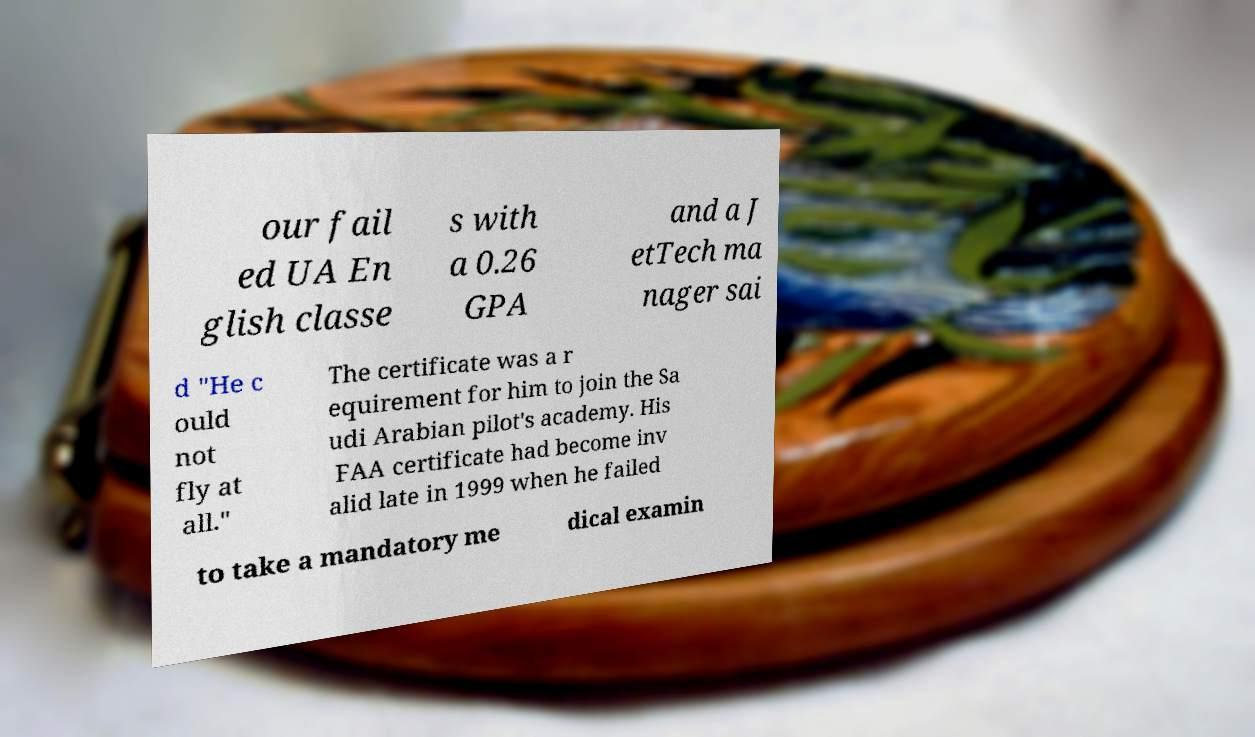There's text embedded in this image that I need extracted. Can you transcribe it verbatim? our fail ed UA En glish classe s with a 0.26 GPA and a J etTech ma nager sai d "He c ould not fly at all." The certificate was a r equirement for him to join the Sa udi Arabian pilot's academy. His FAA certificate had become inv alid late in 1999 when he failed to take a mandatory me dical examin 